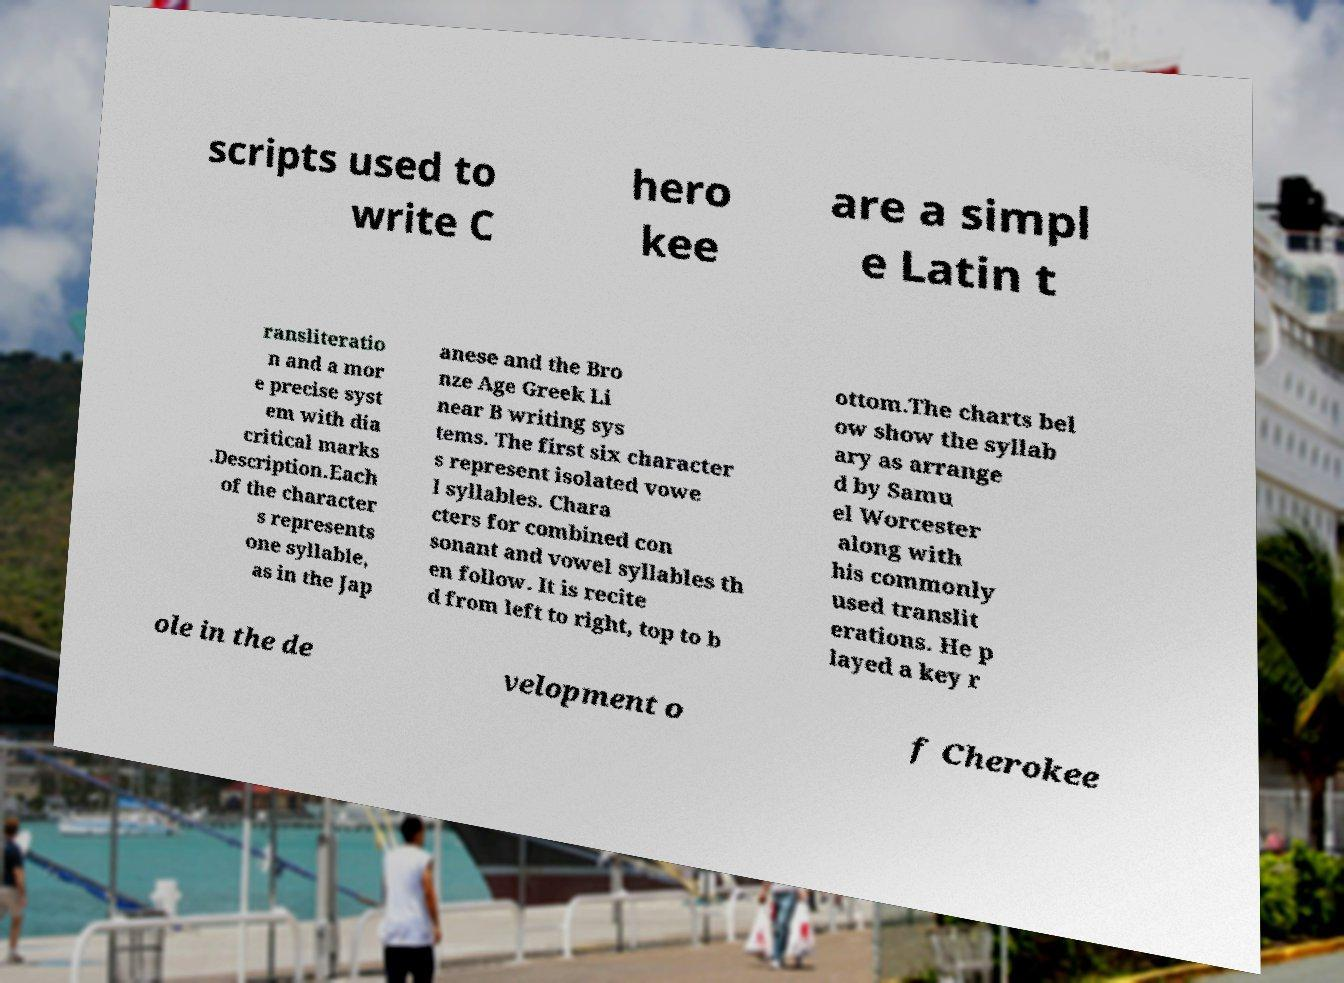Could you extract and type out the text from this image? scripts used to write C hero kee are a simpl e Latin t ransliteratio n and a mor e precise syst em with dia critical marks .Description.Each of the character s represents one syllable, as in the Jap anese and the Bro nze Age Greek Li near B writing sys tems. The first six character s represent isolated vowe l syllables. Chara cters for combined con sonant and vowel syllables th en follow. It is recite d from left to right, top to b ottom.The charts bel ow show the syllab ary as arrange d by Samu el Worcester along with his commonly used translit erations. He p layed a key r ole in the de velopment o f Cherokee 